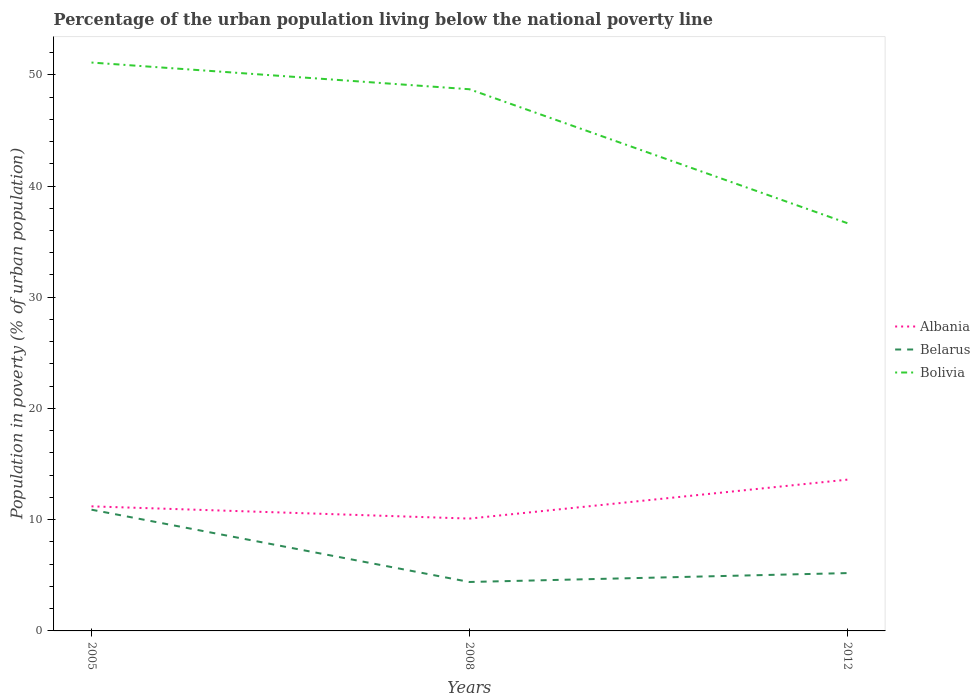Across all years, what is the maximum percentage of the urban population living below the national poverty line in Bolivia?
Provide a succinct answer. 36.66. In which year was the percentage of the urban population living below the national poverty line in Belarus maximum?
Provide a short and direct response. 2008. What is the total percentage of the urban population living below the national poverty line in Belarus in the graph?
Keep it short and to the point. 5.7. What is the difference between the highest and the lowest percentage of the urban population living below the national poverty line in Bolivia?
Make the answer very short. 2. How many lines are there?
Ensure brevity in your answer.  3. Are the values on the major ticks of Y-axis written in scientific E-notation?
Offer a terse response. No. Does the graph contain any zero values?
Your answer should be compact. No. Does the graph contain grids?
Your answer should be very brief. No. Where does the legend appear in the graph?
Your answer should be compact. Center right. What is the title of the graph?
Offer a terse response. Percentage of the urban population living below the national poverty line. What is the label or title of the Y-axis?
Your response must be concise. Population in poverty (% of urban population). What is the Population in poverty (% of urban population) in Albania in 2005?
Provide a short and direct response. 11.2. What is the Population in poverty (% of urban population) in Belarus in 2005?
Offer a terse response. 10.9. What is the Population in poverty (% of urban population) of Bolivia in 2005?
Make the answer very short. 51.1. What is the Population in poverty (% of urban population) in Albania in 2008?
Ensure brevity in your answer.  10.1. What is the Population in poverty (% of urban population) of Belarus in 2008?
Offer a terse response. 4.4. What is the Population in poverty (% of urban population) of Bolivia in 2008?
Your answer should be very brief. 48.7. What is the Population in poverty (% of urban population) of Belarus in 2012?
Provide a short and direct response. 5.2. What is the Population in poverty (% of urban population) of Bolivia in 2012?
Make the answer very short. 36.66. Across all years, what is the maximum Population in poverty (% of urban population) of Albania?
Provide a succinct answer. 13.6. Across all years, what is the maximum Population in poverty (% of urban population) of Bolivia?
Offer a terse response. 51.1. Across all years, what is the minimum Population in poverty (% of urban population) of Belarus?
Your answer should be compact. 4.4. Across all years, what is the minimum Population in poverty (% of urban population) in Bolivia?
Provide a succinct answer. 36.66. What is the total Population in poverty (% of urban population) in Albania in the graph?
Offer a terse response. 34.9. What is the total Population in poverty (% of urban population) in Belarus in the graph?
Your answer should be compact. 20.5. What is the total Population in poverty (% of urban population) of Bolivia in the graph?
Your answer should be compact. 136.46. What is the difference between the Population in poverty (% of urban population) in Belarus in 2005 and that in 2012?
Keep it short and to the point. 5.7. What is the difference between the Population in poverty (% of urban population) in Bolivia in 2005 and that in 2012?
Give a very brief answer. 14.44. What is the difference between the Population in poverty (% of urban population) in Belarus in 2008 and that in 2012?
Make the answer very short. -0.8. What is the difference between the Population in poverty (% of urban population) of Bolivia in 2008 and that in 2012?
Give a very brief answer. 12.04. What is the difference between the Population in poverty (% of urban population) of Albania in 2005 and the Population in poverty (% of urban population) of Bolivia in 2008?
Your answer should be compact. -37.5. What is the difference between the Population in poverty (% of urban population) in Belarus in 2005 and the Population in poverty (% of urban population) in Bolivia in 2008?
Offer a terse response. -37.8. What is the difference between the Population in poverty (% of urban population) in Albania in 2005 and the Population in poverty (% of urban population) in Belarus in 2012?
Ensure brevity in your answer.  6. What is the difference between the Population in poverty (% of urban population) of Albania in 2005 and the Population in poverty (% of urban population) of Bolivia in 2012?
Make the answer very short. -25.46. What is the difference between the Population in poverty (% of urban population) of Belarus in 2005 and the Population in poverty (% of urban population) of Bolivia in 2012?
Provide a short and direct response. -25.76. What is the difference between the Population in poverty (% of urban population) of Albania in 2008 and the Population in poverty (% of urban population) of Bolivia in 2012?
Ensure brevity in your answer.  -26.56. What is the difference between the Population in poverty (% of urban population) in Belarus in 2008 and the Population in poverty (% of urban population) in Bolivia in 2012?
Ensure brevity in your answer.  -32.26. What is the average Population in poverty (% of urban population) of Albania per year?
Keep it short and to the point. 11.63. What is the average Population in poverty (% of urban population) of Belarus per year?
Keep it short and to the point. 6.83. What is the average Population in poverty (% of urban population) in Bolivia per year?
Provide a succinct answer. 45.49. In the year 2005, what is the difference between the Population in poverty (% of urban population) of Albania and Population in poverty (% of urban population) of Bolivia?
Offer a terse response. -39.9. In the year 2005, what is the difference between the Population in poverty (% of urban population) in Belarus and Population in poverty (% of urban population) in Bolivia?
Ensure brevity in your answer.  -40.2. In the year 2008, what is the difference between the Population in poverty (% of urban population) of Albania and Population in poverty (% of urban population) of Bolivia?
Offer a very short reply. -38.6. In the year 2008, what is the difference between the Population in poverty (% of urban population) of Belarus and Population in poverty (% of urban population) of Bolivia?
Offer a terse response. -44.3. In the year 2012, what is the difference between the Population in poverty (% of urban population) in Albania and Population in poverty (% of urban population) in Belarus?
Keep it short and to the point. 8.4. In the year 2012, what is the difference between the Population in poverty (% of urban population) in Albania and Population in poverty (% of urban population) in Bolivia?
Offer a terse response. -23.06. In the year 2012, what is the difference between the Population in poverty (% of urban population) of Belarus and Population in poverty (% of urban population) of Bolivia?
Ensure brevity in your answer.  -31.46. What is the ratio of the Population in poverty (% of urban population) in Albania in 2005 to that in 2008?
Make the answer very short. 1.11. What is the ratio of the Population in poverty (% of urban population) of Belarus in 2005 to that in 2008?
Make the answer very short. 2.48. What is the ratio of the Population in poverty (% of urban population) in Bolivia in 2005 to that in 2008?
Give a very brief answer. 1.05. What is the ratio of the Population in poverty (% of urban population) in Albania in 2005 to that in 2012?
Offer a very short reply. 0.82. What is the ratio of the Population in poverty (% of urban population) in Belarus in 2005 to that in 2012?
Keep it short and to the point. 2.1. What is the ratio of the Population in poverty (% of urban population) of Bolivia in 2005 to that in 2012?
Your answer should be compact. 1.39. What is the ratio of the Population in poverty (% of urban population) of Albania in 2008 to that in 2012?
Provide a short and direct response. 0.74. What is the ratio of the Population in poverty (% of urban population) of Belarus in 2008 to that in 2012?
Offer a very short reply. 0.85. What is the ratio of the Population in poverty (% of urban population) in Bolivia in 2008 to that in 2012?
Offer a terse response. 1.33. What is the difference between the highest and the second highest Population in poverty (% of urban population) in Belarus?
Keep it short and to the point. 5.7. What is the difference between the highest and the lowest Population in poverty (% of urban population) of Bolivia?
Keep it short and to the point. 14.44. 